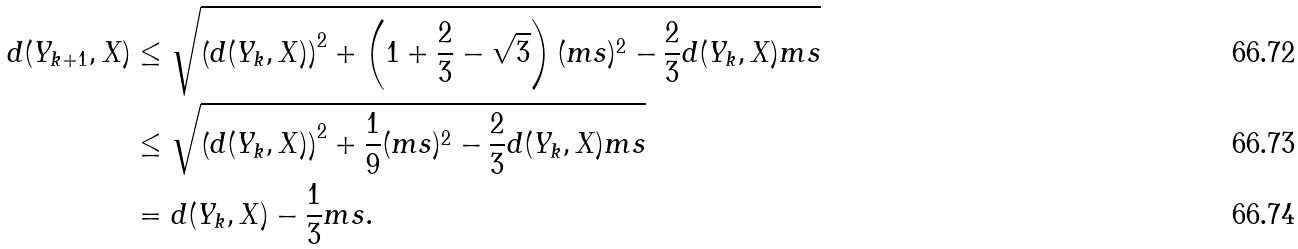Convert formula to latex. <formula><loc_0><loc_0><loc_500><loc_500>d ( Y _ { k + 1 } , X ) & \leq \sqrt { \left ( d ( Y _ { k } , X ) \right ) ^ { 2 } + \left ( 1 + \frac { 2 } { 3 } - \sqrt { 3 } \right ) ( m s ) ^ { 2 } - \frac { 2 } { 3 } d ( Y _ { k } , X ) m s } \\ & \leq \sqrt { \left ( d ( Y _ { k } , X ) \right ) ^ { 2 } + \frac { 1 } { 9 } ( m s ) ^ { 2 } - \frac { 2 } { 3 } d ( Y _ { k } , X ) m s } \\ & = d ( Y _ { k } , X ) - \frac { 1 } { 3 } m s .</formula> 